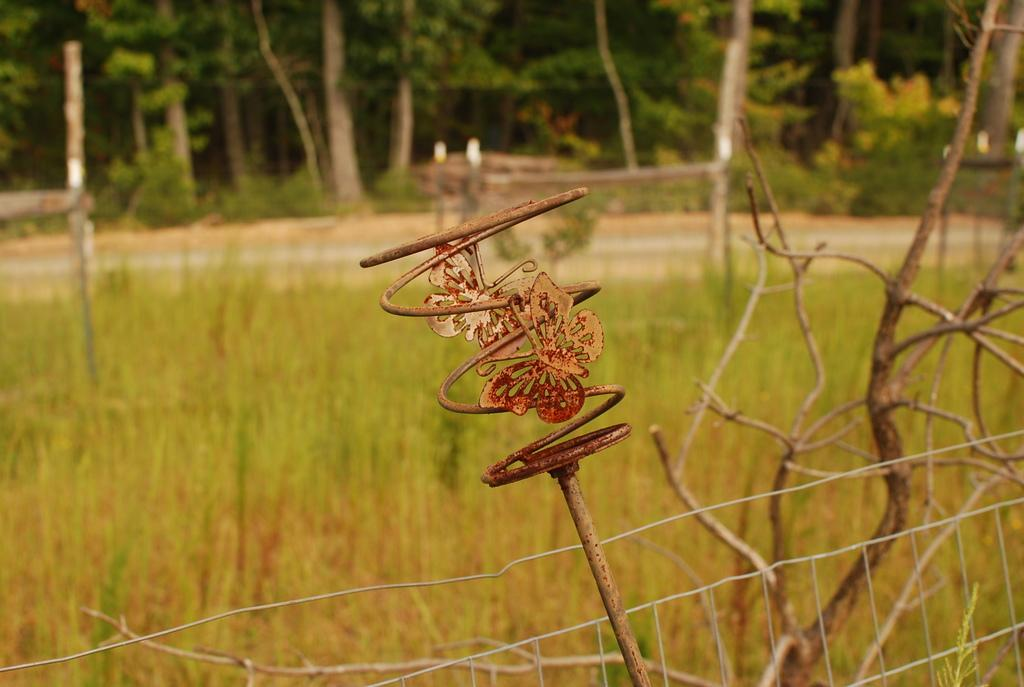What type of material is the object in the image made of? The object in the image is made of metal. What can be seen in the image besides the metal object? There is a fence and grass visible in the image. What is in the background of the image? There are trees in the background of the image. How does the bridge connect the two sides of the image? There is no bridge present in the image. What type of wish can be granted by the metal object in the image? The metal object in the image is not associated with granting wishes. 